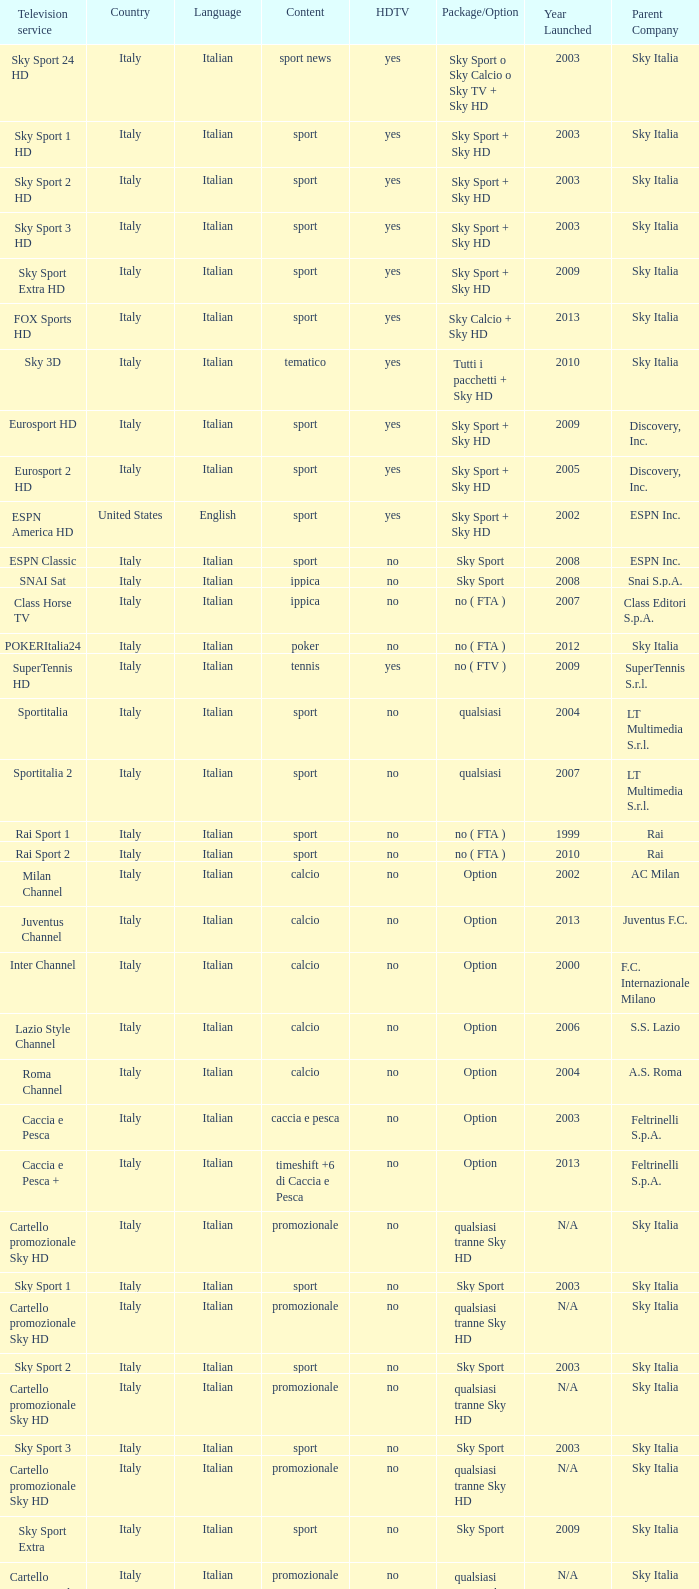What is Package/Option, when Content is Tennis? No ( ftv ). 